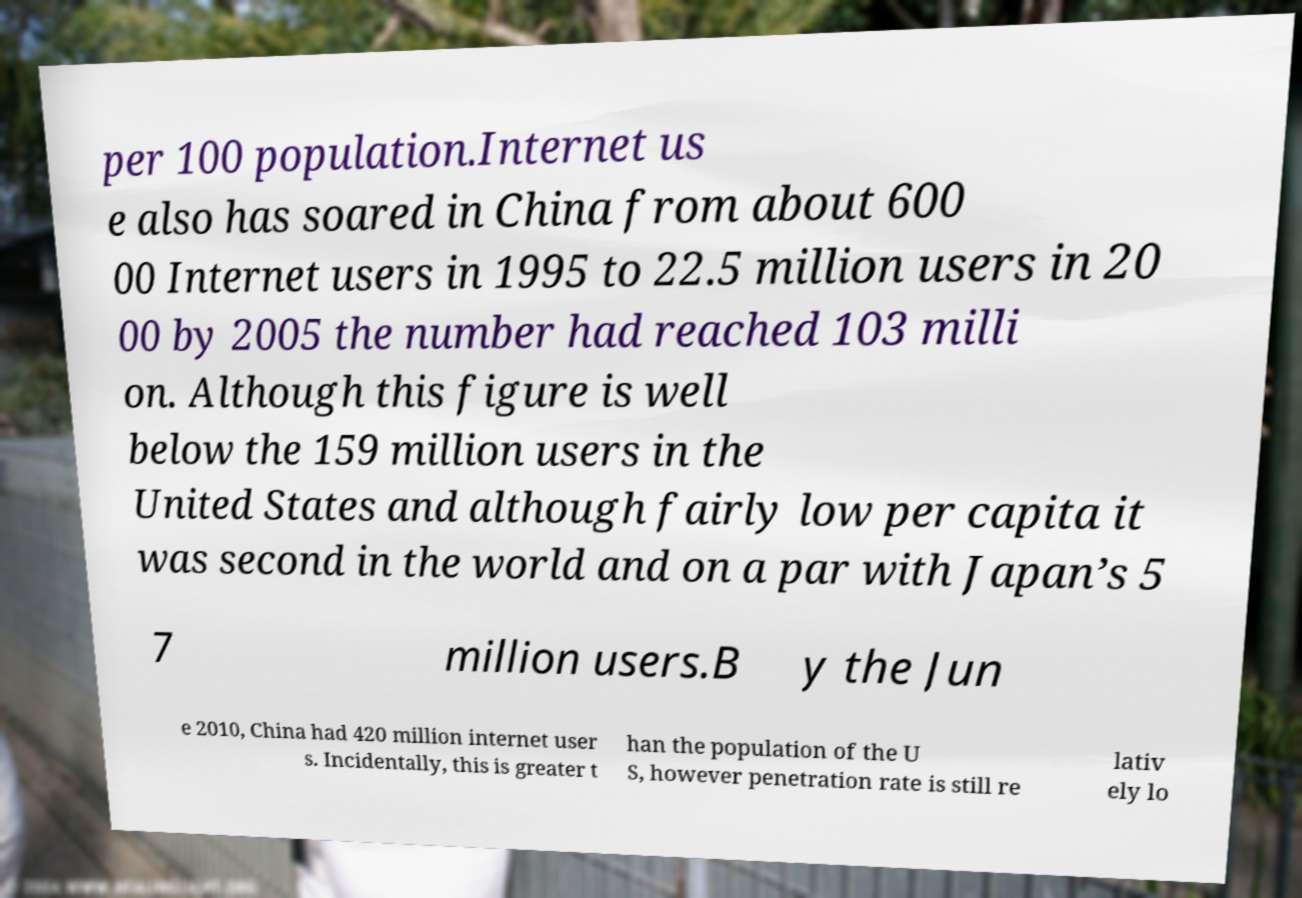Could you extract and type out the text from this image? per 100 population.Internet us e also has soared in China from about 600 00 Internet users in 1995 to 22.5 million users in 20 00 by 2005 the number had reached 103 milli on. Although this figure is well below the 159 million users in the United States and although fairly low per capita it was second in the world and on a par with Japan’s 5 7 million users.B y the Jun e 2010, China had 420 million internet user s. Incidentally, this is greater t han the population of the U S, however penetration rate is still re lativ ely lo 